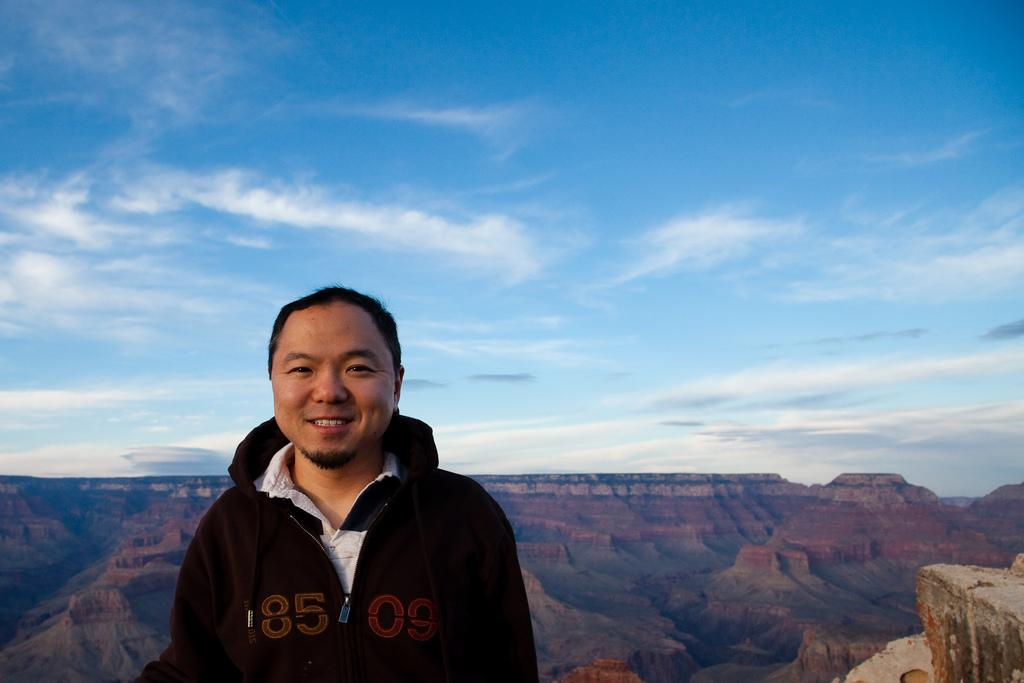What is the main subject of the image? There is a man standing in the middle of the image. What is the man's facial expression? The man is smiling. What type of landscape can be seen behind the man? There are hills visible behind the man. What is visible at the top of the image? There are clouds and the sky visible at the top of the image. What type of grape is the man holding in the image? There is no grape present in the image; the man is not holding anything. What reward is the man receiving for his actions in the image? There is no indication of a reward or any actions being performed by the man in the image. 